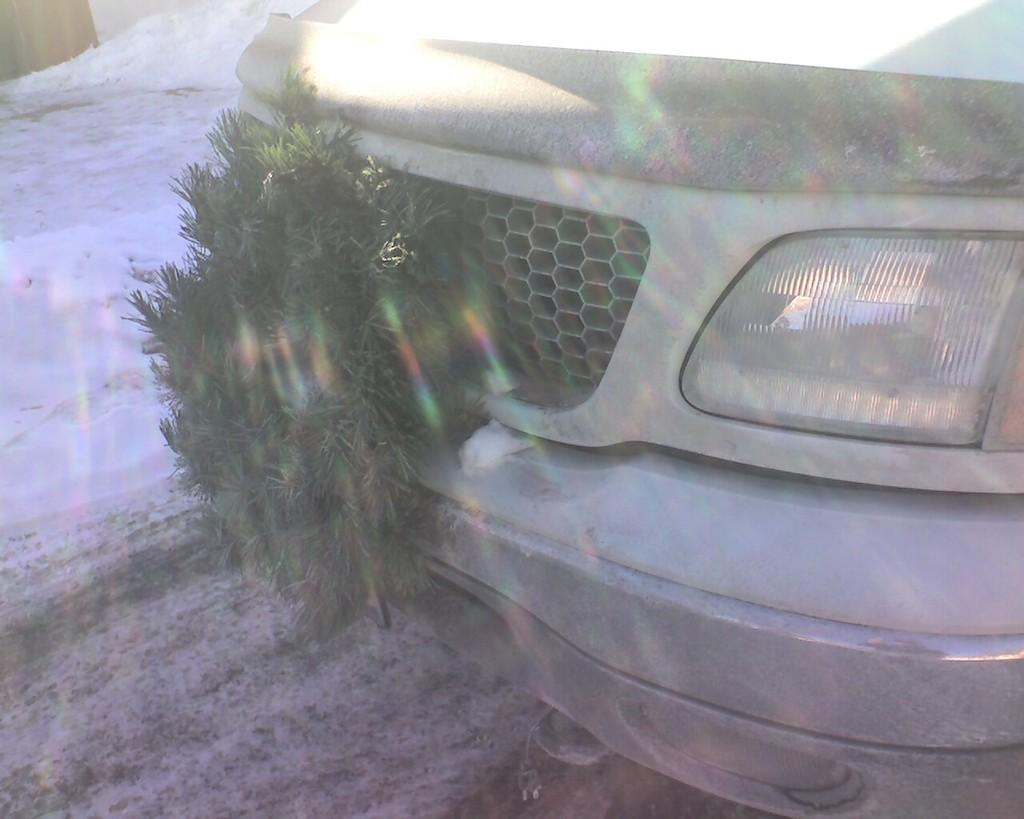What is located on the ground in the image? There is a vehicle on the ground in the image. What type of vegetation can be seen in the image? Leaves are visible in the image. What is the weather condition in the background of the image? There is snow in the background of the image. What else can be seen in the background of the image? There are objects visible in the background of the image. What type of lunch is being served by the actor in the image? There is no actor or lunch present in the image. 